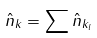<formula> <loc_0><loc_0><loc_500><loc_500>\hat { n } _ { k } = \sum \hat { n } _ { k _ { l } }</formula> 